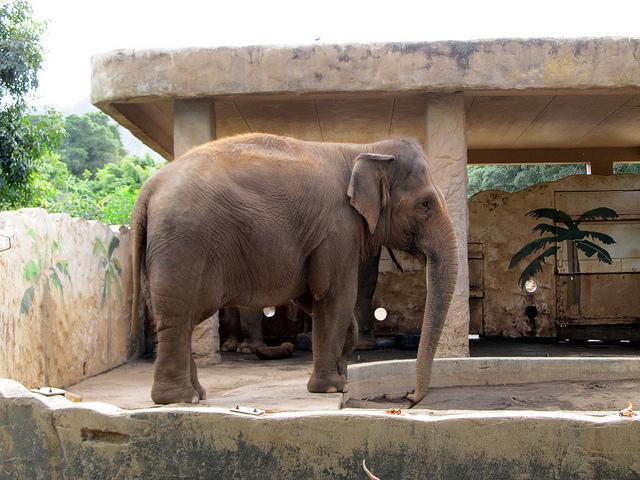How many elephants are in the scene?
Give a very brief answer. 1. How many chairs are seen in the picture?
Give a very brief answer. 0. 